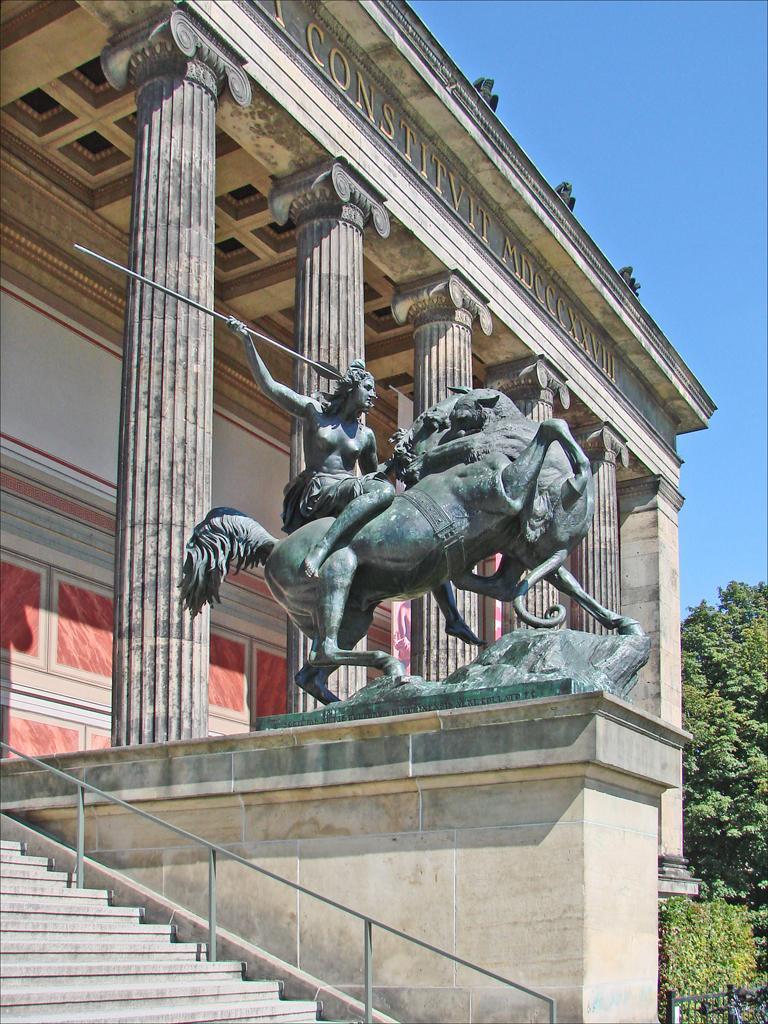Please provide a concise description of this image. In this image we can see a building, in front of the building, we can see a statue, there are some trees, pillars and a staircase, also we can see the text on the building, in the background we can see the sky. 